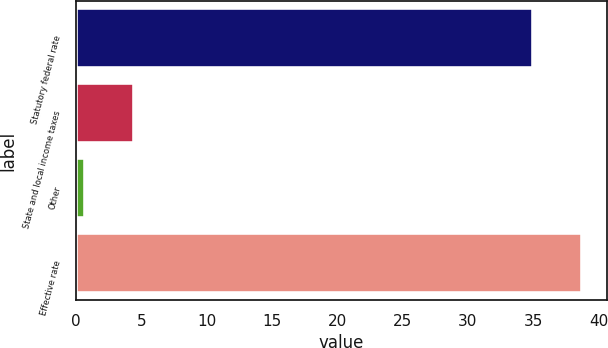Convert chart. <chart><loc_0><loc_0><loc_500><loc_500><bar_chart><fcel>Statutory federal rate<fcel>State and local income taxes<fcel>Other<fcel>Effective rate<nl><fcel>35<fcel>4.44<fcel>0.7<fcel>38.74<nl></chart> 